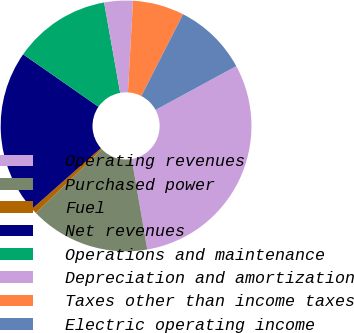Convert chart. <chart><loc_0><loc_0><loc_500><loc_500><pie_chart><fcel>Operating revenues<fcel>Purchased power<fcel>Fuel<fcel>Net revenues<fcel>Operations and maintenance<fcel>Depreciation and amortization<fcel>Taxes other than income taxes<fcel>Electric operating income<nl><fcel>30.21%<fcel>15.47%<fcel>0.73%<fcel>21.18%<fcel>12.52%<fcel>3.68%<fcel>6.63%<fcel>9.57%<nl></chart> 